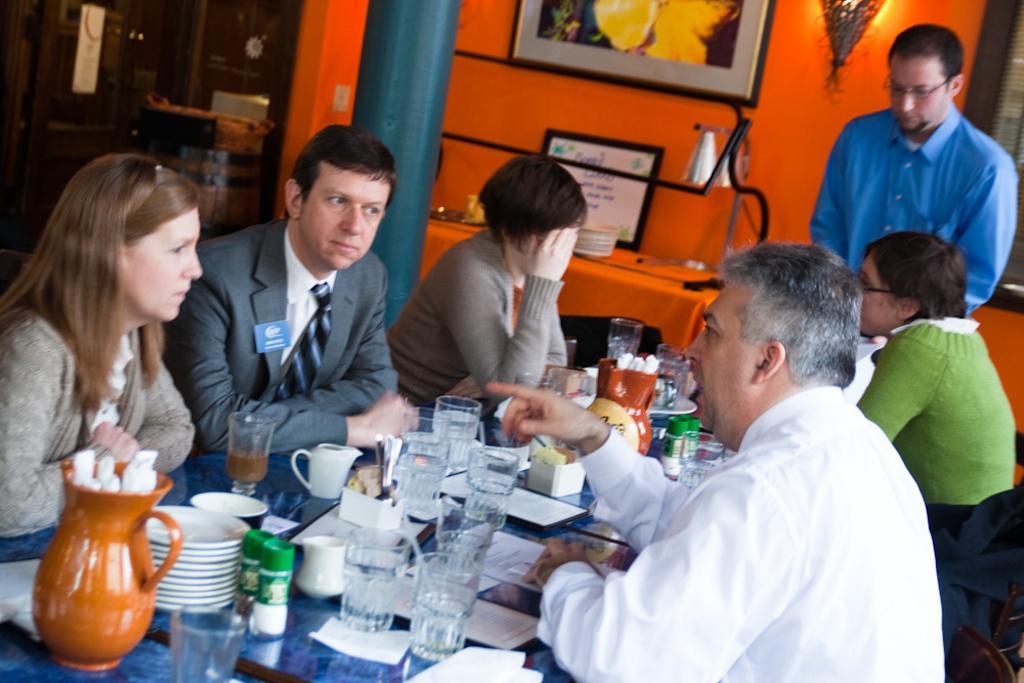In one or two sentences, can you explain what this image depicts? In this image there are the persons sitting around the table ,on the table there are the glasses and jars ,plates kept on the table ,on the right side a person wearing a blue color shirt he is standing in front of the people. And the background i can see a orange color wall and on the wall i can see a photo frame attached to the wall. 